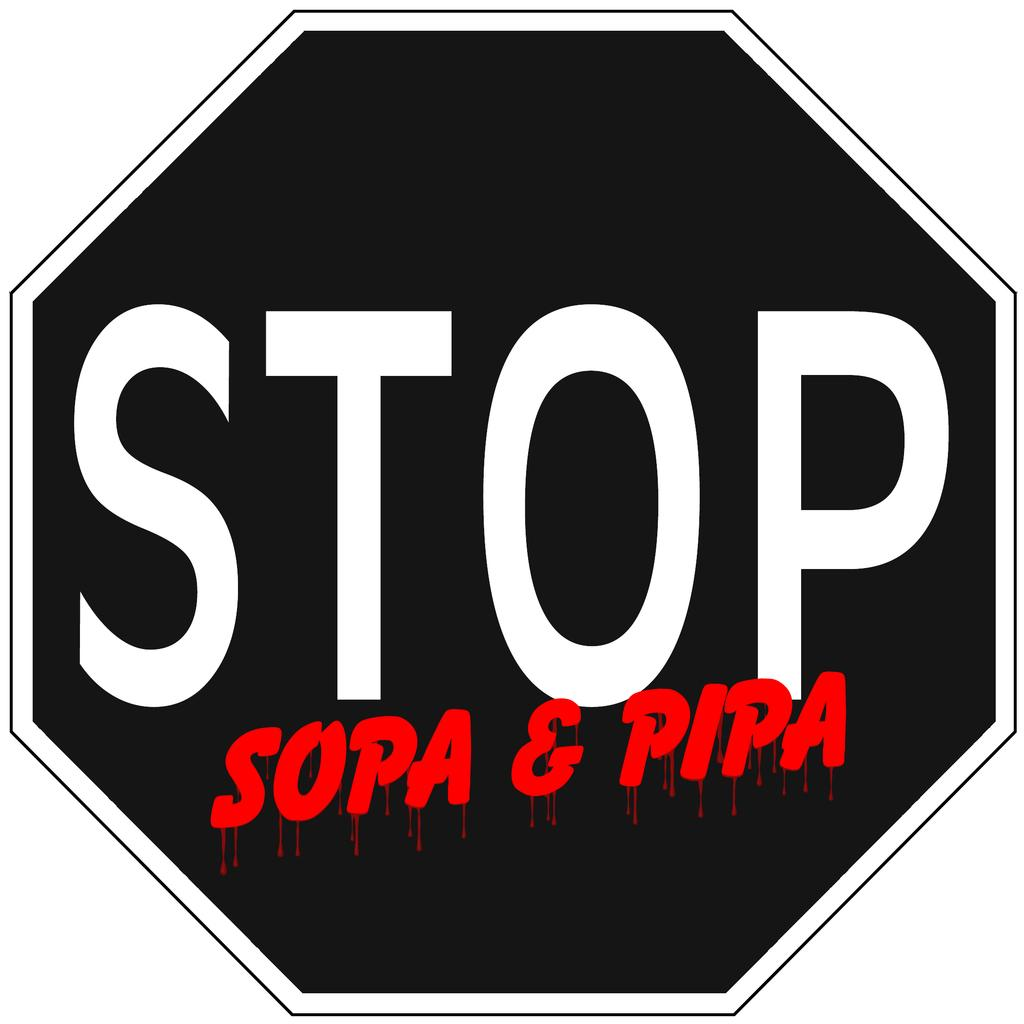Provide a one-sentence caption for the provided image. a stop sign that is black and red in color. 